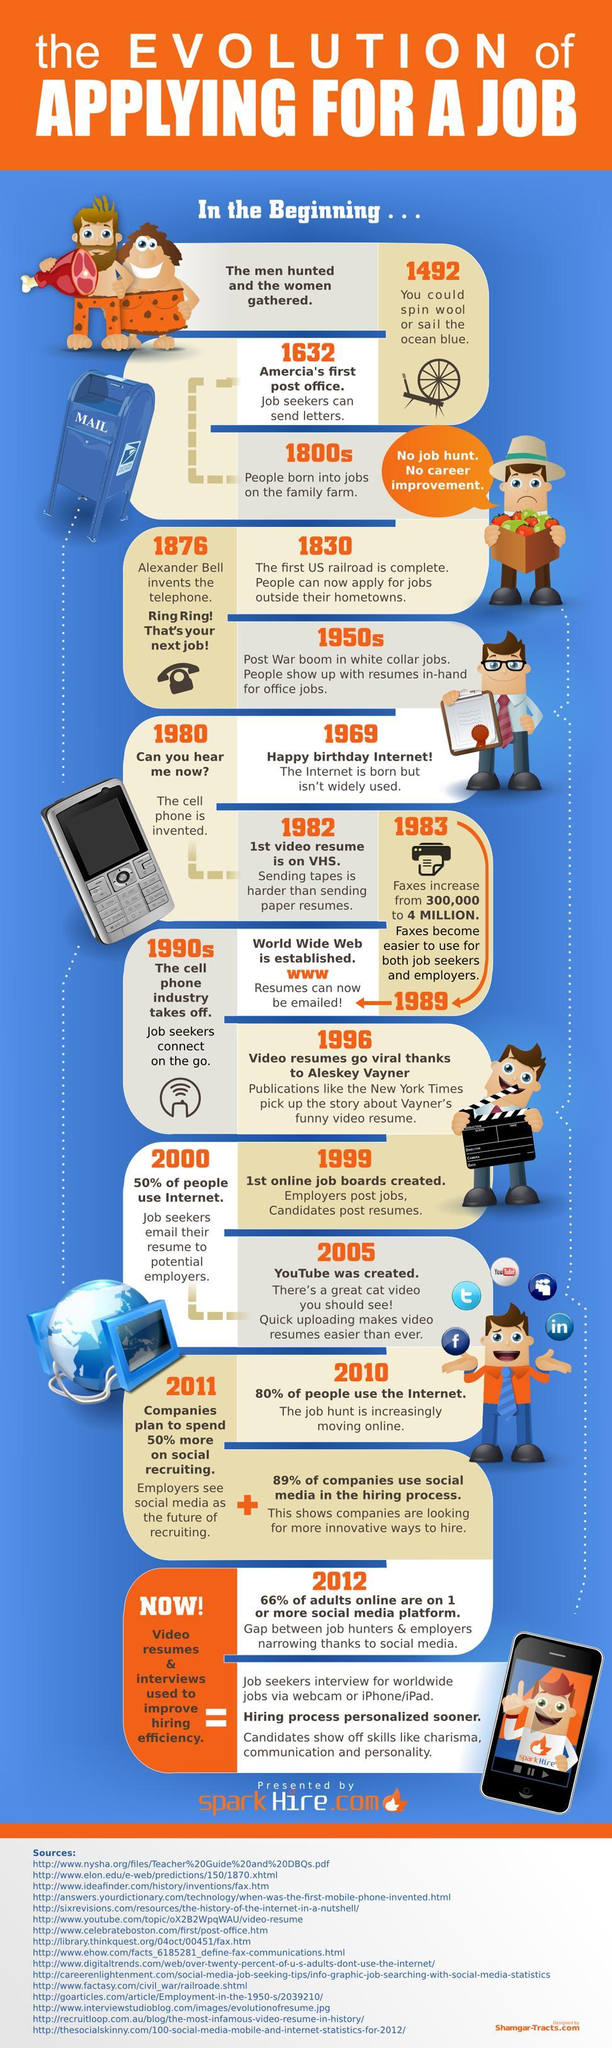how many years after the internet was youtube created?
Answer the question with a short phrase. 36 What is the percentage of people who did not use internet in 2000? 50% How many years before Alexander Bell invented the telephone was America's first post office built? 244 How many years after Alexander Bell invented the telephone was the internet born? 93 